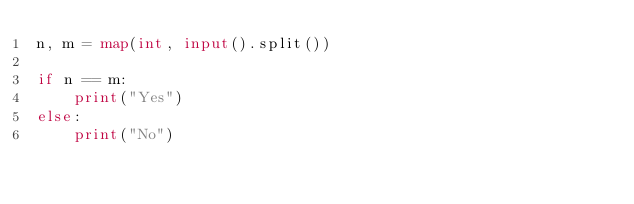<code> <loc_0><loc_0><loc_500><loc_500><_Python_>n, m = map(int, input().split())

if n == m:
    print("Yes")
else:
    print("No")
</code> 